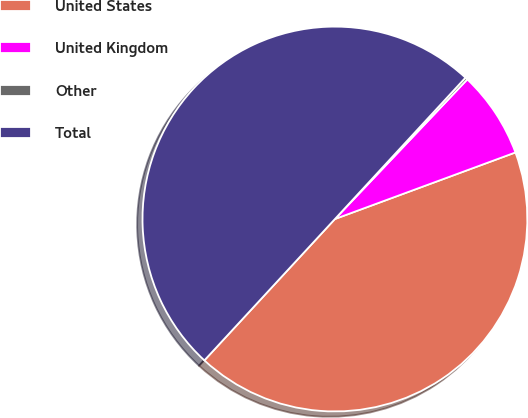<chart> <loc_0><loc_0><loc_500><loc_500><pie_chart><fcel>United States<fcel>United Kingdom<fcel>Other<fcel>Total<nl><fcel>42.49%<fcel>7.3%<fcel>0.21%<fcel>50.0%<nl></chart> 